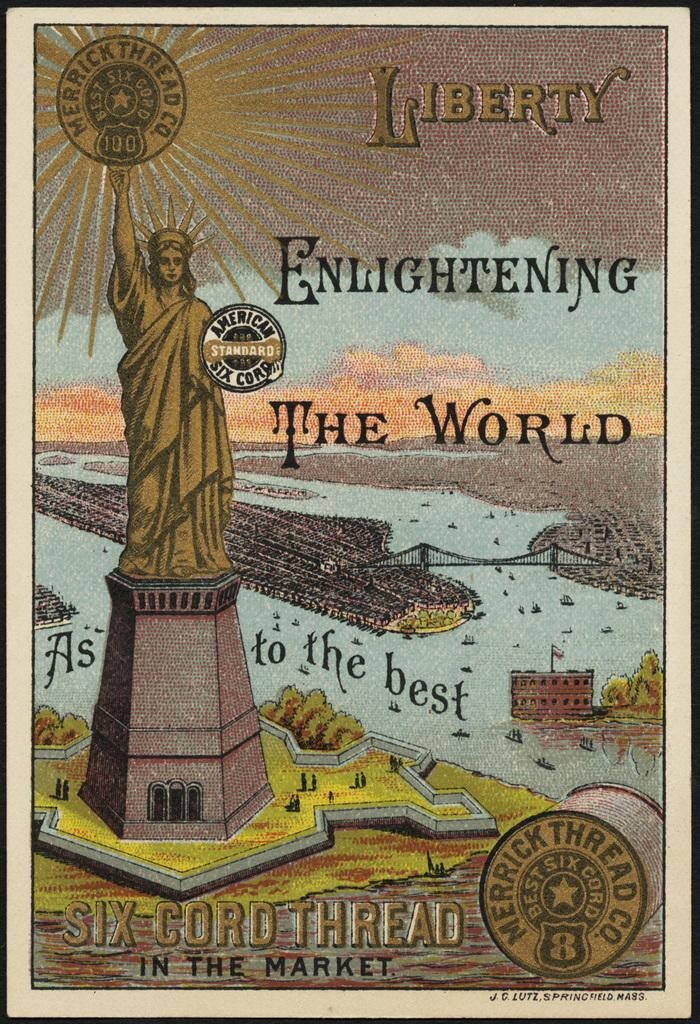Provide a one-sentence caption for the provided image. The poster for Six Cord Thread features the Statue of Liberty and the phrase, "Liberty Enlightening the World.". 